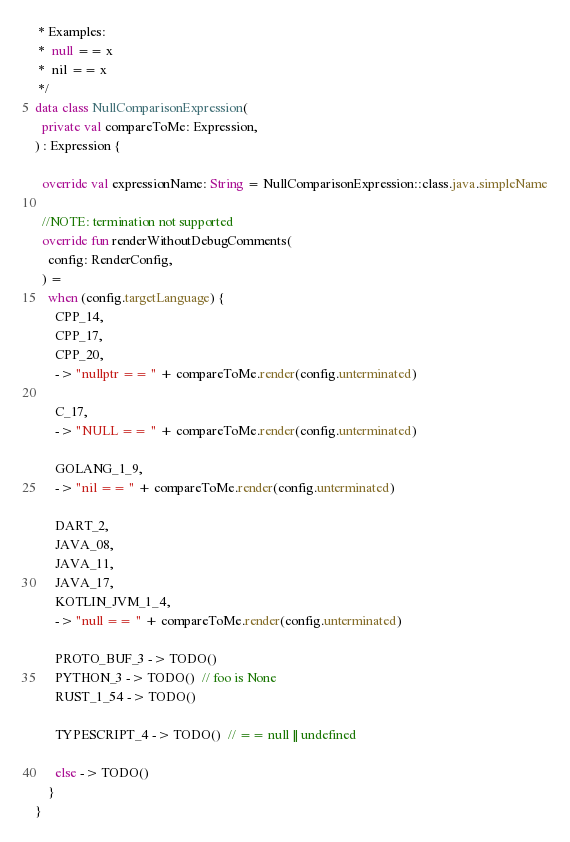Convert code to text. <code><loc_0><loc_0><loc_500><loc_500><_Kotlin_> * Examples:
 *  null == x
 *  nil == x
 */
data class NullComparisonExpression(
  private val compareToMe: Expression,
) : Expression {

  override val expressionName: String = NullComparisonExpression::class.java.simpleName

  //NOTE: termination not supported
  override fun renderWithoutDebugComments(
    config: RenderConfig,
  ) =
    when (config.targetLanguage) {
      CPP_14,
      CPP_17,
      CPP_20,
      -> "nullptr == " + compareToMe.render(config.unterminated)

      C_17,
      -> "NULL == " + compareToMe.render(config.unterminated)

      GOLANG_1_9,
      -> "nil == " + compareToMe.render(config.unterminated)

      DART_2,
      JAVA_08,
      JAVA_11,
      JAVA_17,
      KOTLIN_JVM_1_4,
      -> "null == " + compareToMe.render(config.unterminated)

      PROTO_BUF_3 -> TODO()
      PYTHON_3 -> TODO()  // foo is None
      RUST_1_54 -> TODO()

      TYPESCRIPT_4 -> TODO()  // == null || undefined

      else -> TODO()
    }
}
</code> 